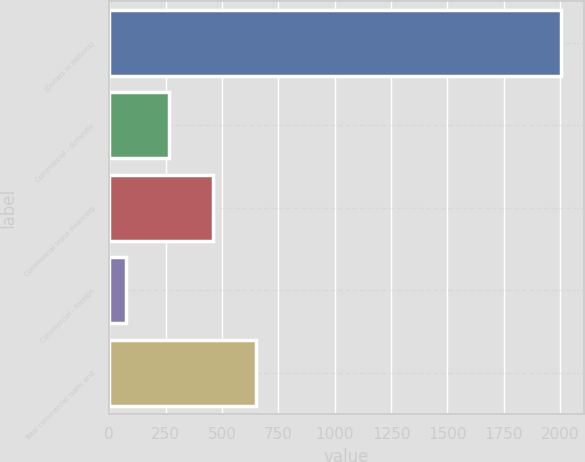<chart> <loc_0><loc_0><loc_500><loc_500><bar_chart><fcel>(Dollars in millions)<fcel>Commercial - domestic<fcel>Commercial lease financing<fcel>Commercial - foreign<fcel>Total commercial loans and<nl><fcel>2005<fcel>265.3<fcel>458.6<fcel>72<fcel>651.9<nl></chart> 